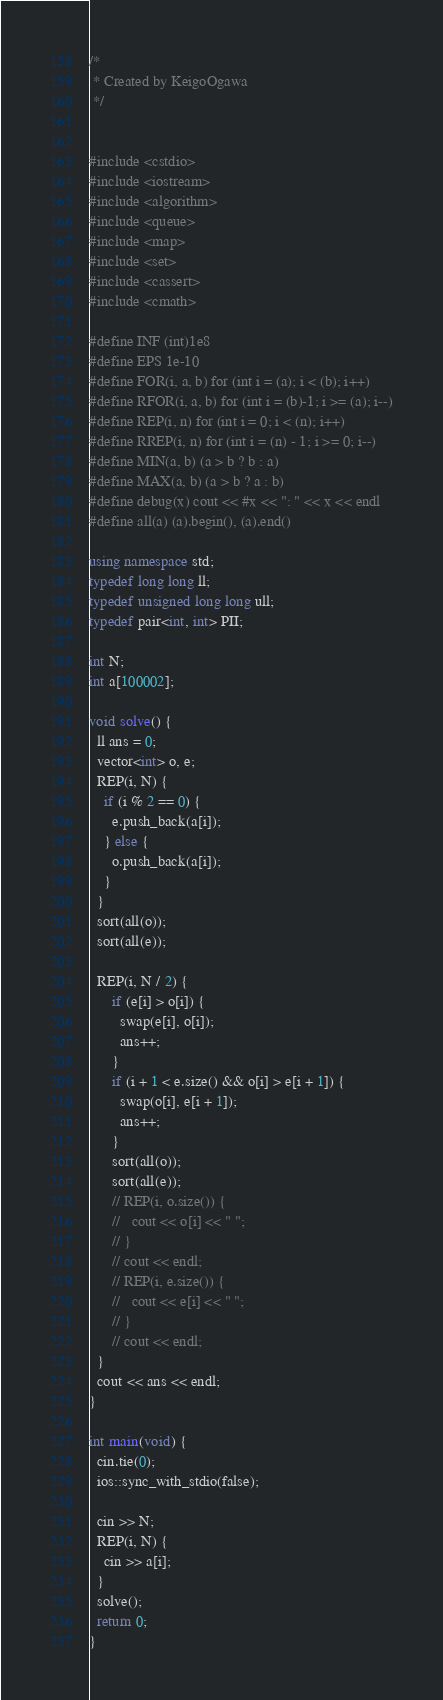Convert code to text. <code><loc_0><loc_0><loc_500><loc_500><_C++_>/*
 * Created by KeigoOgawa
 */


#include <cstdio>
#include <iostream>
#include <algorithm>
#include <queue>
#include <map>
#include <set>
#include <cassert>
#include <cmath>

#define INF (int)1e8
#define EPS 1e-10
#define FOR(i, a, b) for (int i = (a); i < (b); i++)
#define RFOR(i, a, b) for (int i = (b)-1; i >= (a); i--)
#define REP(i, n) for (int i = 0; i < (n); i++)
#define RREP(i, n) for (int i = (n) - 1; i >= 0; i--)
#define MIN(a, b) (a > b ? b : a)
#define MAX(a, b) (a > b ? a : b)
#define debug(x) cout << #x << ": " << x << endl
#define all(a) (a).begin(), (a).end()

using namespace std;
typedef long long ll;
typedef unsigned long long ull;
typedef pair<int, int> PII;

int N;
int a[100002];

void solve() {
  ll ans = 0;
  vector<int> o, e;
  REP(i, N) {
    if (i % 2 == 0) {
      e.push_back(a[i]);
    } else {
      o.push_back(a[i]);
    }
  }
  sort(all(o));
  sort(all(e));

  REP(i, N / 2) {
      if (e[i] > o[i]) {
        swap(e[i], o[i]);
        ans++;
      }
      if (i + 1 < e.size() && o[i] > e[i + 1]) {
        swap(o[i], e[i + 1]);
        ans++;
      }
      sort(all(o));
      sort(all(e));
      // REP(i, o.size()) {
      //   cout << o[i] << " ";
      // }
      // cout << endl;
      // REP(i, e.size()) {
      //   cout << e[i] << " ";
      // }
      // cout << endl;
  }
  cout << ans << endl;
}

int main(void) {
  cin.tie(0);
  ios::sync_with_stdio(false);

  cin >> N;
  REP(i, N) {
    cin >> a[i];
  }
  solve();
  return 0;
}
</code> 